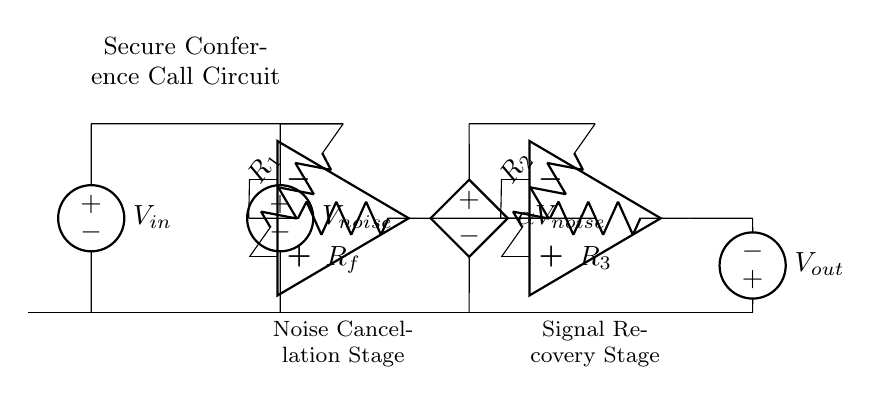What is the purpose of the noise source in this circuit? The noise source, represented by the voltage source labeled V_noise, is used to simulate interference that may occur during conference calls, allowing the circuit to effectively cancel out this unwanted noise.
Answer: Simulate interference What role does the summing amplifier play? The summing amplifier combines the input signal and the noise signal, creating a single output that represents both elements to facilitate the next stage of noise cancellation.
Answer: Combine signals What is the reference voltage for the controlled voltage source? The controlled voltage source labeled αV_noise is a scaled version of the noise source voltage and provides a reference for estimating the noise to be subtracted.
Answer: αV_noise How many resistors are used in the circuit? There are three resistors in the circuit, labeled R1, R2, and R3, which are used for controlling the gain and scaling the input signals appropriately.
Answer: Three What does V_out represent in this circuit? V_out is the final output voltage of the circuit after noise cancellation, providing the clean signal intended for secure conference calls without interference.
Answer: Clean signal Why is the noise estimation circuit necessary? The noise estimation circuit, which includes the controlled voltage source, determines the level of noise to be subtracted from the combined signal to enhance clarity in the output, ensuring effective noise cancellation during calls.
Answer: Enhance clarity 